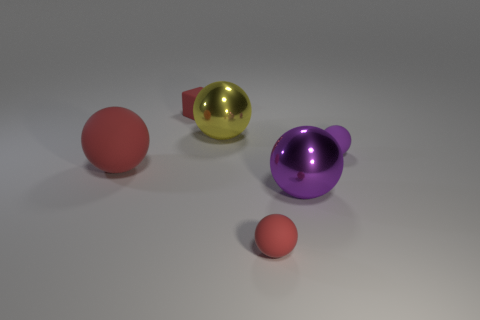There is a large yellow shiny object; how many big purple objects are on the left side of it?
Ensure brevity in your answer.  0. There is a thing to the left of the small red cube; does it have the same color as the matte block?
Keep it short and to the point. Yes. How many matte blocks have the same size as the purple metallic ball?
Provide a succinct answer. 0. There is a big purple thing that is made of the same material as the yellow object; what is its shape?
Provide a short and direct response. Sphere. Is there another sphere of the same color as the large rubber sphere?
Make the answer very short. Yes. What is the material of the large purple ball?
Make the answer very short. Metal. How many objects are either tiny purple matte objects or yellow metallic spheres?
Give a very brief answer. 2. What is the size of the purple ball that is on the left side of the tiny purple thing?
Your answer should be very brief. Large. What number of other things are made of the same material as the tiny purple thing?
Offer a terse response. 3. Are there any small red blocks behind the matte block behind the small purple rubber sphere?
Your answer should be very brief. No. 